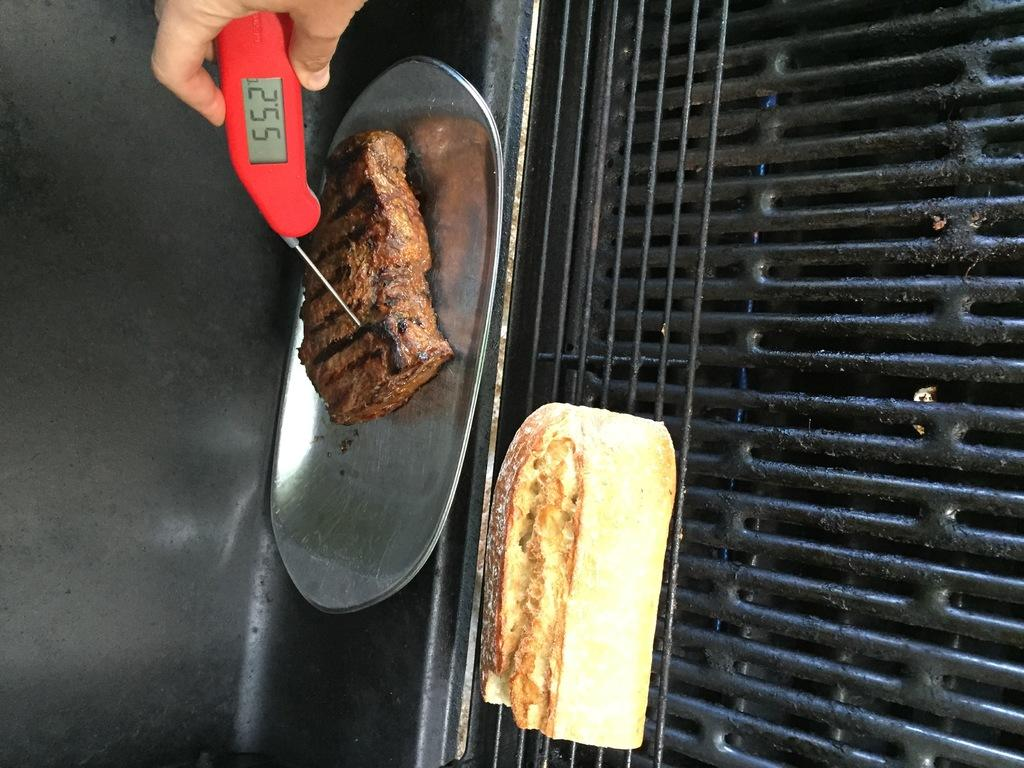<image>
Relay a brief, clear account of the picture shown. a person with a thermometer that reads 55.2 